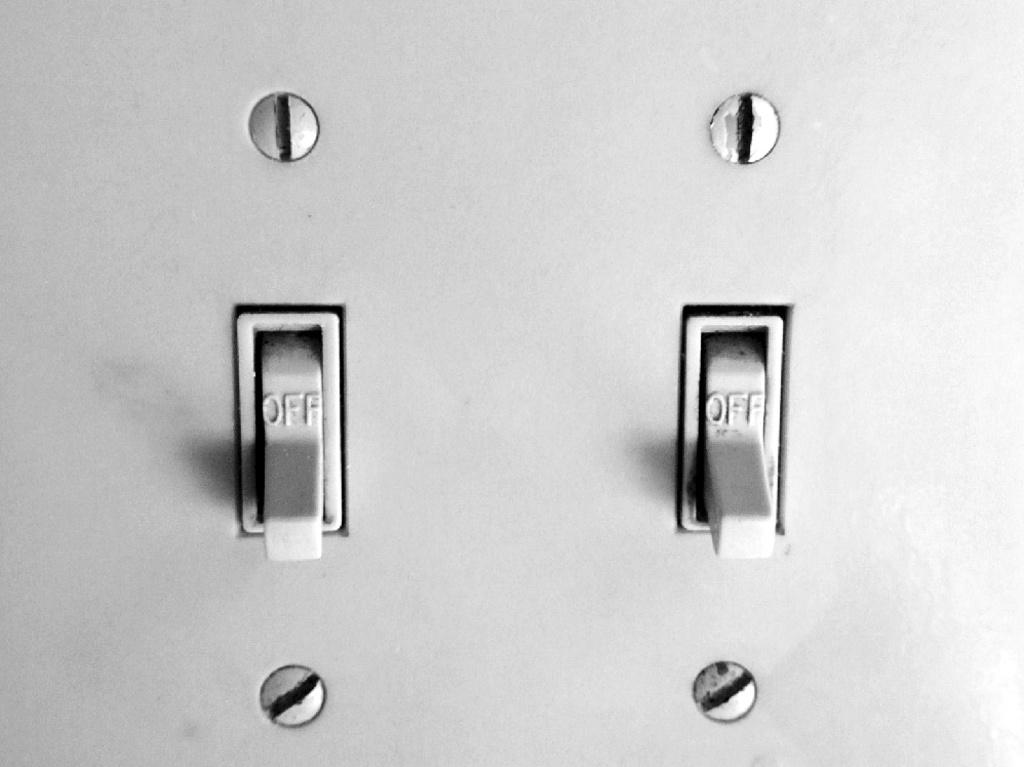What do the switches do?
Offer a terse response. Turn off. Are these switches on?
Give a very brief answer. No. 